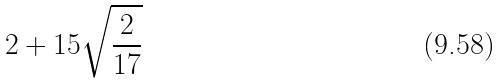<formula> <loc_0><loc_0><loc_500><loc_500>2 + 1 5 \sqrt { \frac { 2 } { 1 7 } }</formula> 